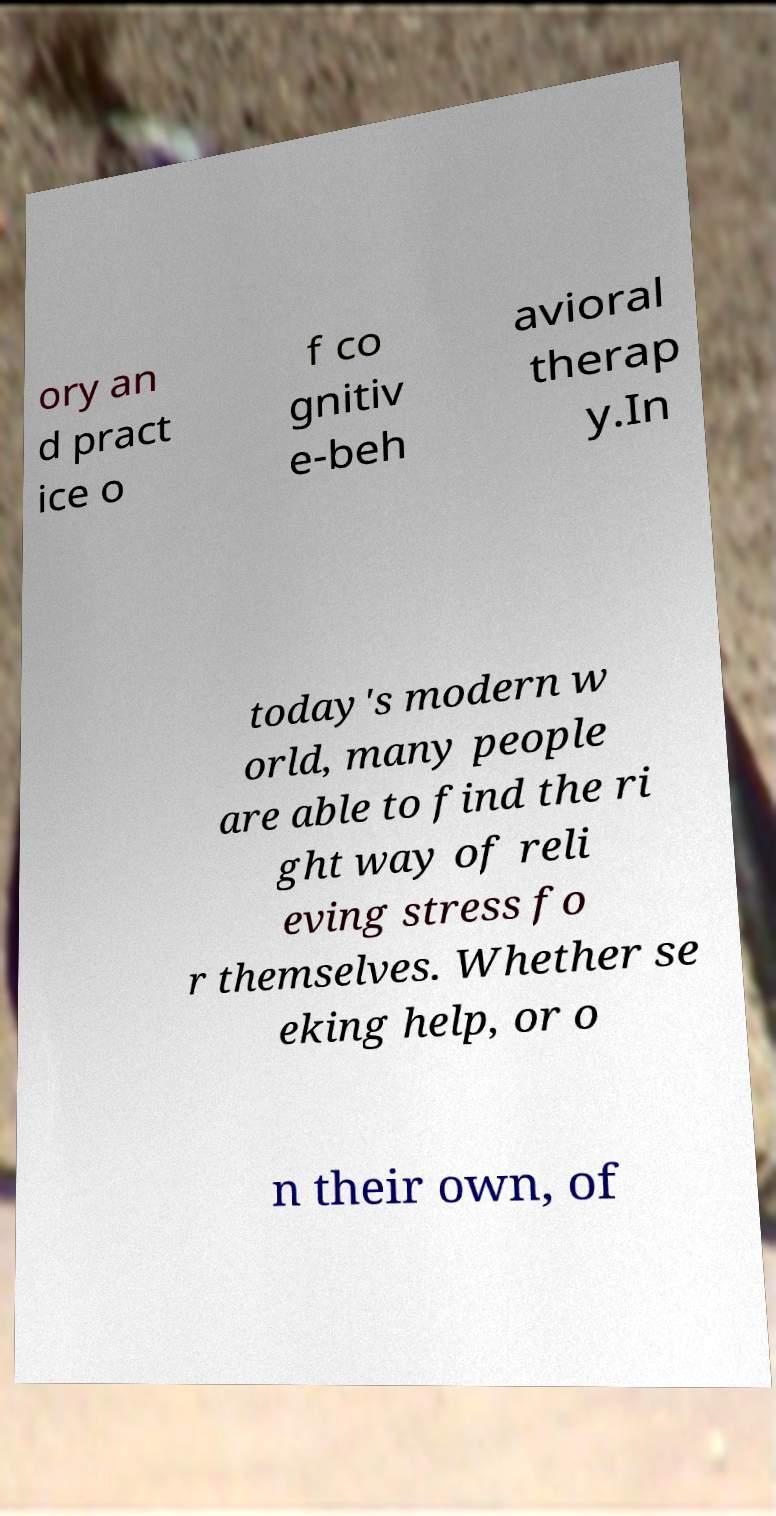For documentation purposes, I need the text within this image transcribed. Could you provide that? ory an d pract ice o f co gnitiv e-beh avioral therap y.In today's modern w orld, many people are able to find the ri ght way of reli eving stress fo r themselves. Whether se eking help, or o n their own, of 